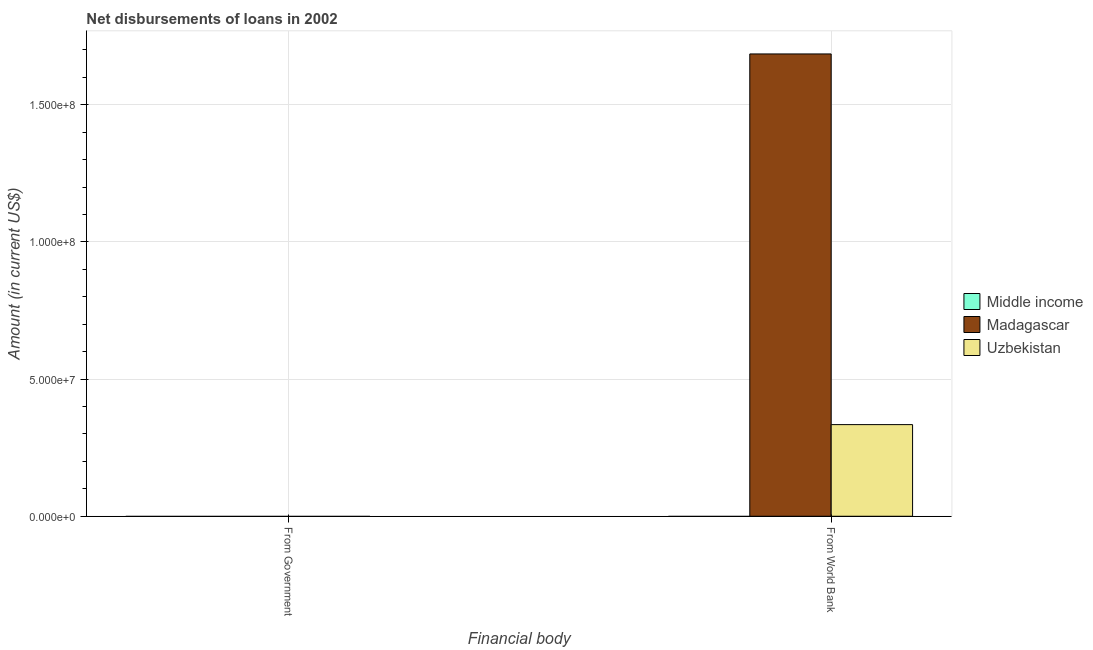How many different coloured bars are there?
Your answer should be very brief. 2. Are the number of bars per tick equal to the number of legend labels?
Give a very brief answer. No. How many bars are there on the 1st tick from the left?
Provide a short and direct response. 0. How many bars are there on the 1st tick from the right?
Ensure brevity in your answer.  2. What is the label of the 1st group of bars from the left?
Your answer should be very brief. From Government. What is the net disbursements of loan from government in Uzbekistan?
Your response must be concise. 0. Across all countries, what is the maximum net disbursements of loan from world bank?
Make the answer very short. 1.69e+08. In which country was the net disbursements of loan from world bank maximum?
Offer a very short reply. Madagascar. What is the total net disbursements of loan from government in the graph?
Provide a succinct answer. 0. What is the difference between the net disbursements of loan from world bank in Uzbekistan and that in Madagascar?
Provide a short and direct response. -1.35e+08. What is the difference between the net disbursements of loan from government in Middle income and the net disbursements of loan from world bank in Madagascar?
Your answer should be compact. -1.69e+08. What is the average net disbursements of loan from government per country?
Provide a short and direct response. 0. In how many countries, is the net disbursements of loan from world bank greater than 160000000 US$?
Give a very brief answer. 1. In how many countries, is the net disbursements of loan from government greater than the average net disbursements of loan from government taken over all countries?
Your answer should be compact. 0. Are all the bars in the graph horizontal?
Offer a terse response. No. Are the values on the major ticks of Y-axis written in scientific E-notation?
Give a very brief answer. Yes. Does the graph contain grids?
Your response must be concise. Yes. How many legend labels are there?
Provide a succinct answer. 3. What is the title of the graph?
Provide a short and direct response. Net disbursements of loans in 2002. What is the label or title of the X-axis?
Make the answer very short. Financial body. What is the label or title of the Y-axis?
Provide a succinct answer. Amount (in current US$). What is the Amount (in current US$) of Middle income in From Government?
Your response must be concise. 0. What is the Amount (in current US$) in Madagascar in From Government?
Give a very brief answer. 0. What is the Amount (in current US$) in Uzbekistan in From Government?
Provide a short and direct response. 0. What is the Amount (in current US$) of Middle income in From World Bank?
Keep it short and to the point. 0. What is the Amount (in current US$) of Madagascar in From World Bank?
Keep it short and to the point. 1.69e+08. What is the Amount (in current US$) in Uzbekistan in From World Bank?
Your answer should be compact. 3.34e+07. Across all Financial body, what is the maximum Amount (in current US$) of Madagascar?
Give a very brief answer. 1.69e+08. Across all Financial body, what is the maximum Amount (in current US$) in Uzbekistan?
Provide a short and direct response. 3.34e+07. What is the total Amount (in current US$) in Middle income in the graph?
Keep it short and to the point. 0. What is the total Amount (in current US$) of Madagascar in the graph?
Give a very brief answer. 1.69e+08. What is the total Amount (in current US$) in Uzbekistan in the graph?
Your answer should be compact. 3.34e+07. What is the average Amount (in current US$) in Madagascar per Financial body?
Give a very brief answer. 8.43e+07. What is the average Amount (in current US$) of Uzbekistan per Financial body?
Your response must be concise. 1.67e+07. What is the difference between the Amount (in current US$) in Madagascar and Amount (in current US$) in Uzbekistan in From World Bank?
Offer a very short reply. 1.35e+08. What is the difference between the highest and the lowest Amount (in current US$) in Madagascar?
Give a very brief answer. 1.69e+08. What is the difference between the highest and the lowest Amount (in current US$) of Uzbekistan?
Keep it short and to the point. 3.34e+07. 